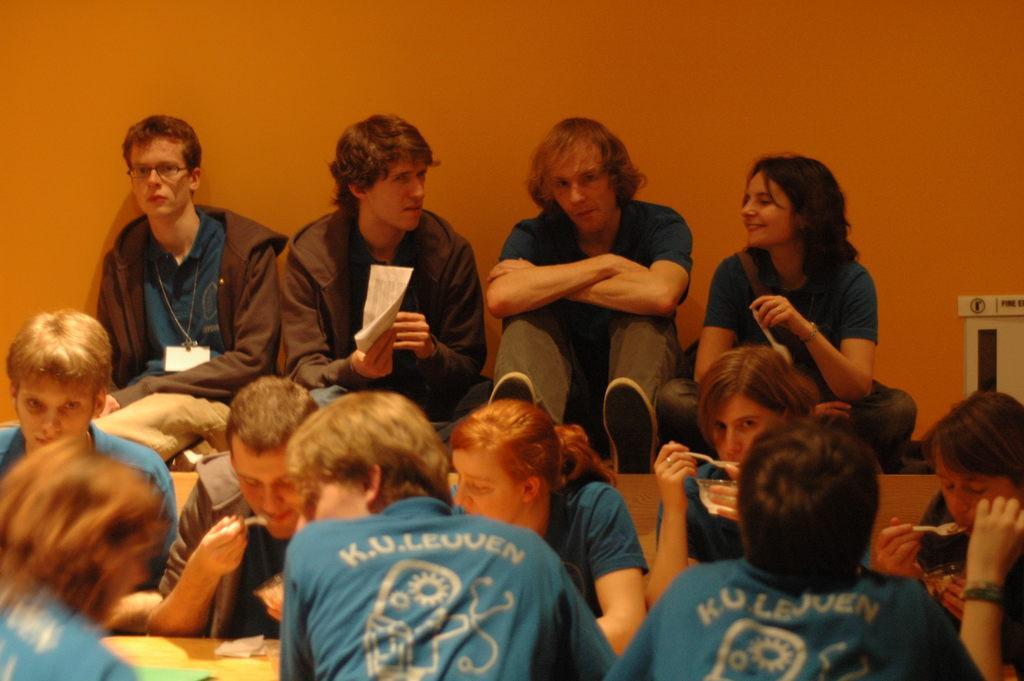How would you summarize this image in a sentence or two? In the image there are few persons sitting in front of wall, in the front there are few persons having food, the background wall is of orange color, they all wore same blue color t-shirt. 